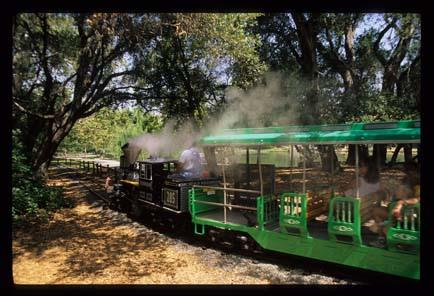What food is the same color as the largest portion of this vehicle?

Choices:
A) corn
B) lemon
C) cherry
D) spinach spinach 